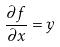<formula> <loc_0><loc_0><loc_500><loc_500>\frac { \partial f } { \partial x } = y</formula> 